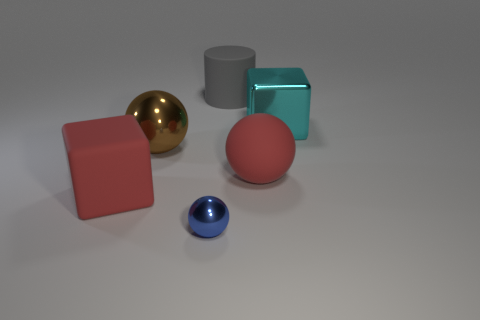What is the size of the rubber object that is the same color as the matte ball?
Offer a very short reply. Large. There is a large thing that is the same color as the large matte block; what shape is it?
Provide a short and direct response. Sphere. Is there anything else that has the same color as the small object?
Provide a short and direct response. No. Are there fewer objects that are on the right side of the big red matte cube than large matte cubes?
Provide a short and direct response. No. Are there more large green rubber cylinders than tiny blue objects?
Offer a terse response. No. Are there any balls that are right of the tiny blue shiny object in front of the matte thing behind the matte ball?
Provide a succinct answer. Yes. How many other objects are there of the same size as the red block?
Give a very brief answer. 4. Are there any tiny objects behind the red rubber block?
Ensure brevity in your answer.  No. Does the rubber sphere have the same color as the metal thing that is in front of the rubber cube?
Provide a succinct answer. No. There is a shiny ball that is in front of the cube on the left side of the big red matte object to the right of the cylinder; what is its color?
Your response must be concise. Blue. 